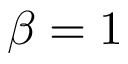Convert formula to latex. <formula><loc_0><loc_0><loc_500><loc_500>\beta = 1</formula> 